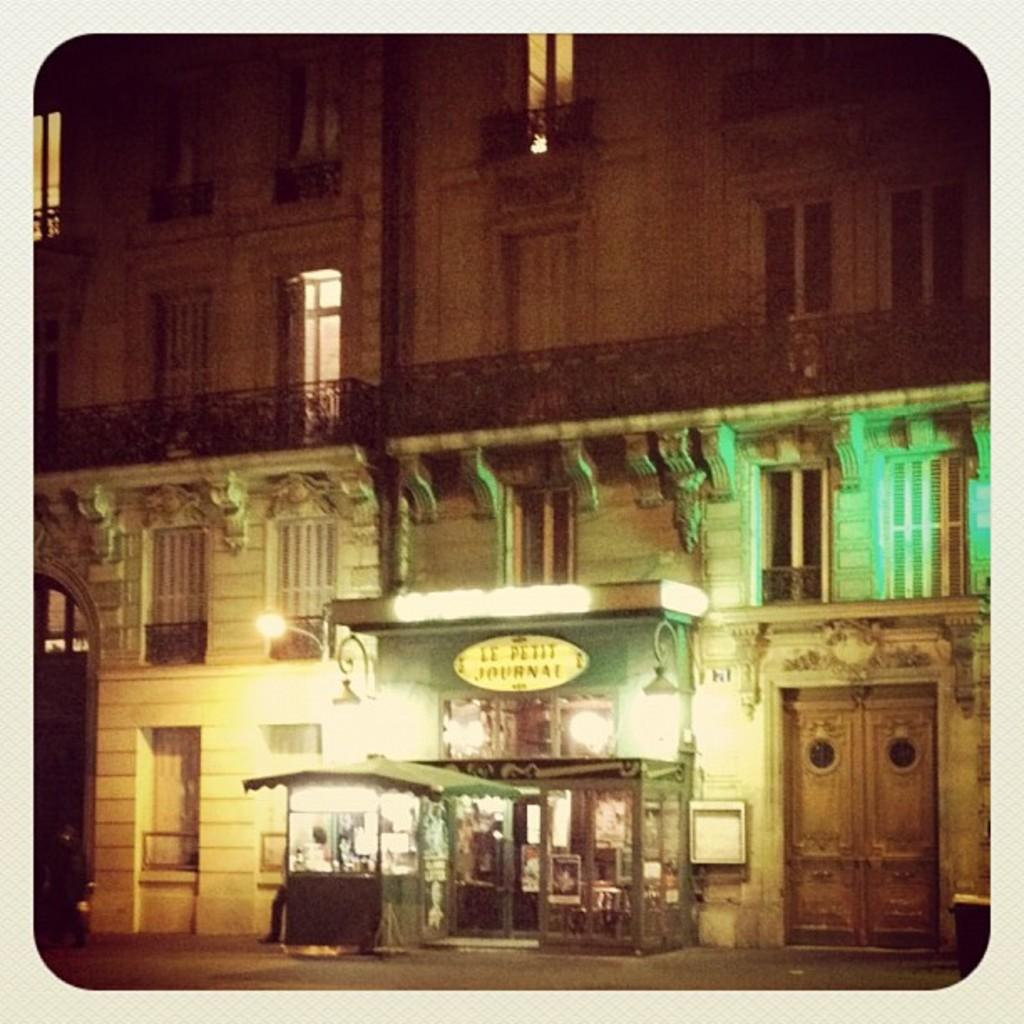What type of objects can be seen in the image? There are small objects in the image. What else is present in the image besides the small objects? There are lights and a building in the image. What feature of the building is visible in the image? There are windows in the image. What type of trail can be seen in the image? There is no trail present in the image. What color is the sweater worn by the person in the image? There is no person or sweater present in the image. 